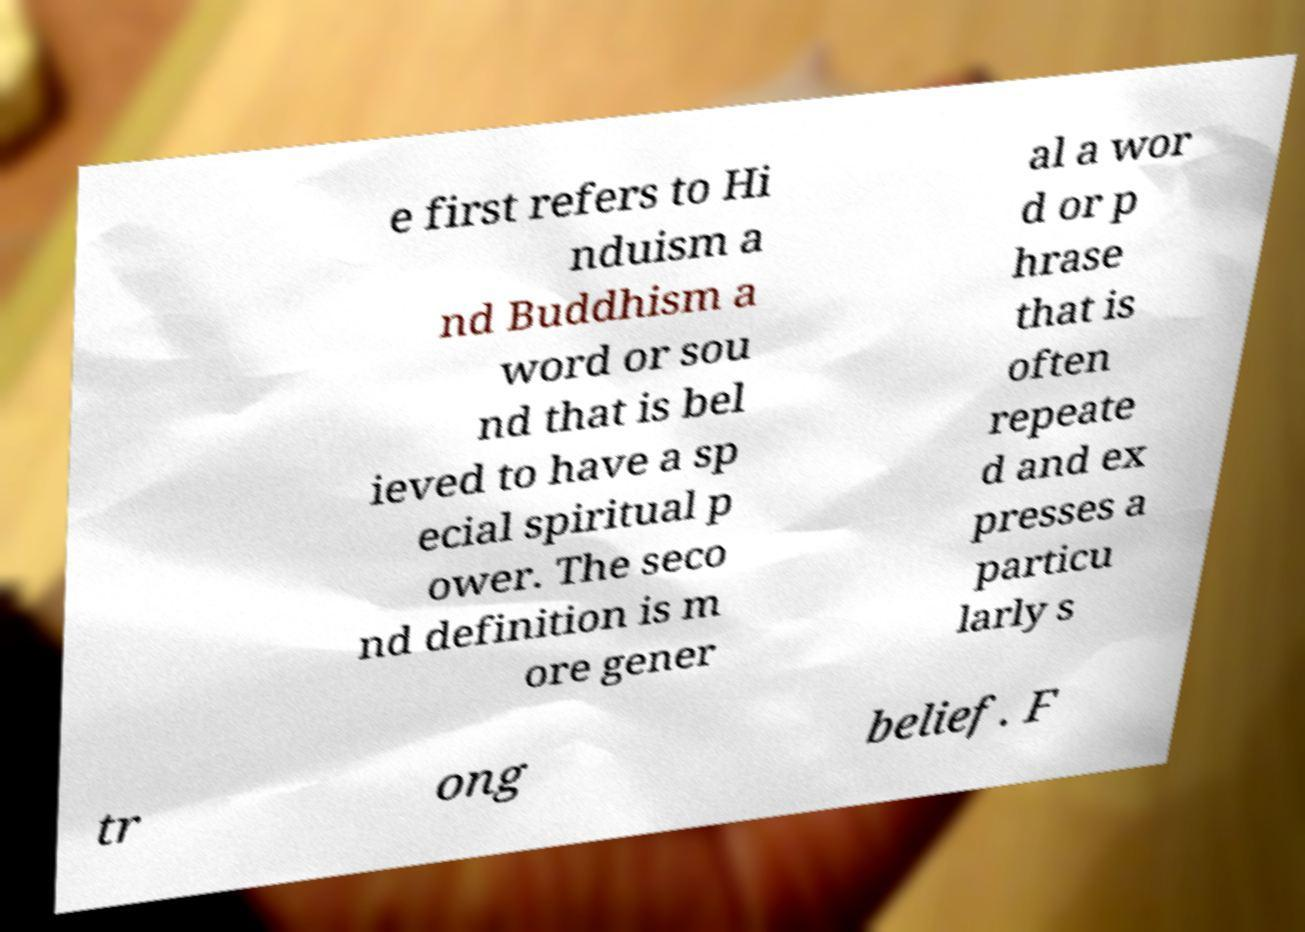Could you assist in decoding the text presented in this image and type it out clearly? e first refers to Hi nduism a nd Buddhism a word or sou nd that is bel ieved to have a sp ecial spiritual p ower. The seco nd definition is m ore gener al a wor d or p hrase that is often repeate d and ex presses a particu larly s tr ong belief. F 